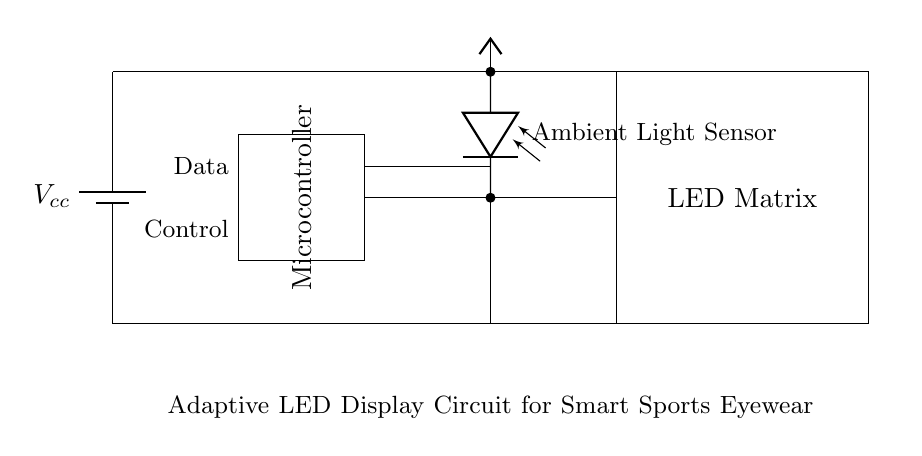What component is responsible for measuring ambient light? The component responsible for measuring ambient light is the photodiode, located at the top right of the circuit diagram.
Answer: photodiode What does the microcontroller control in this circuit? The microcontroller controls the data and provides signals to adapt the LED matrix based on input from the ambient light sensor.
Answer: LED matrix How many main components are in this circuit? The main components in this circuit are four: a battery, a microcontroller, an ambient light sensor, and an LED matrix.
Answer: four What is the power source voltage denoted as in the circuit? The power source voltage is denoted as Vcc in the circuit, which indicates the voltage provided to the circuit components.
Answer: Vcc What is the purpose of the LED matrix in this circuit? The purpose of the LED matrix is to enhance visibility by adapting the display based on ambient light conditions.
Answer: enhance visibility What type of circuit is this? This circuit is a digital circuit designed for smart sports eyewear, involving adaptive elements for display.
Answer: digital 